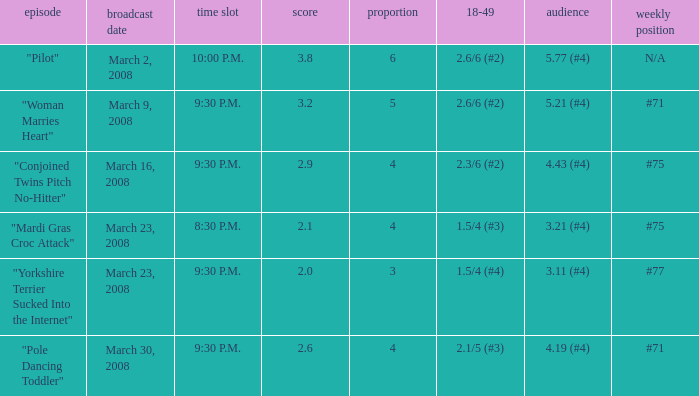What is the total ratings on share less than 4? 1.0. 